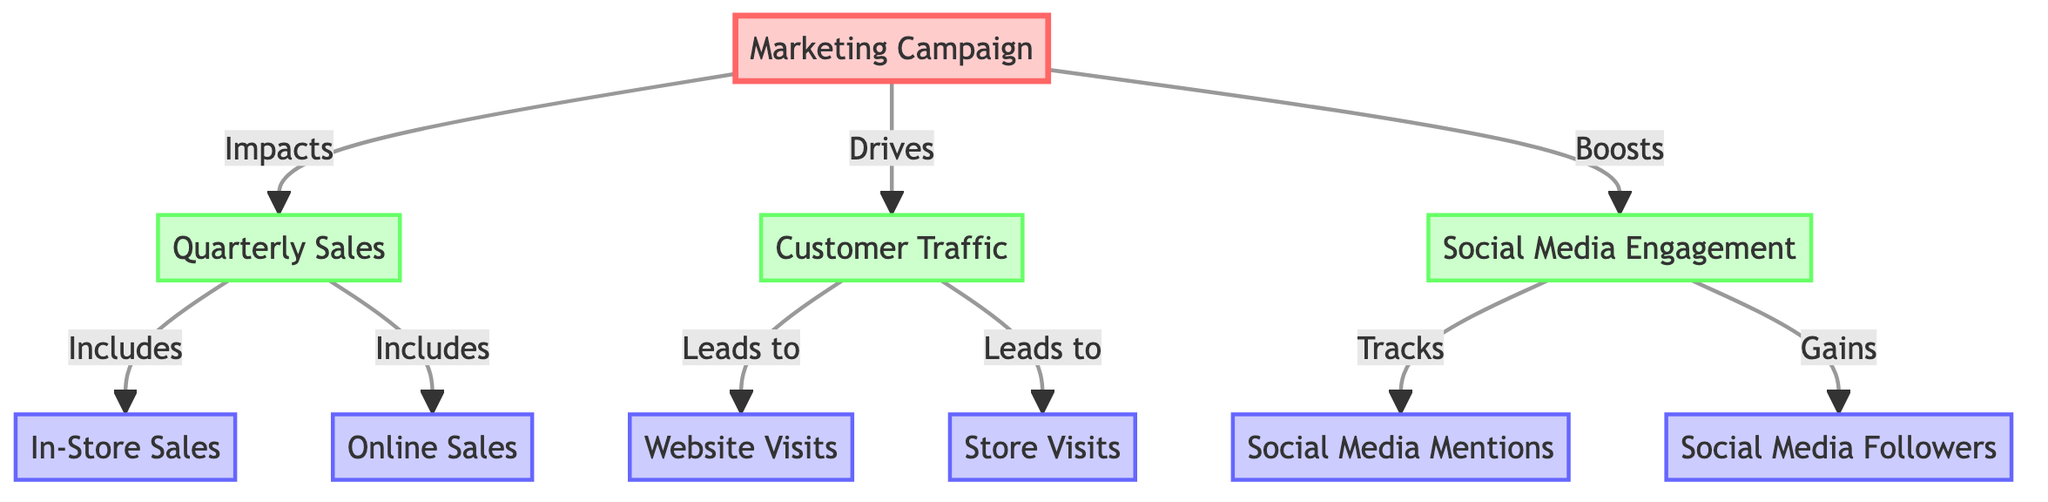What's the primary node in this diagram? The primary node, which serves as the starting point for the relationships connecting various metrics, is "Marketing Campaign." It is depicted prominently with the label indicating its role.
Answer: Marketing Campaign How many main metric nodes are there? The main metric nodes are "Quarterly Sales," "Customer Traffic," and "Social Media Engagement." Counting these nodes provides the answer.
Answer: Three What does the marketing campaign impact directly? The marketing campaign directly impacts quarterly sales, as indicated by the connection labeled "Impacts." This relationship shows a straightforward influence in the diagram.
Answer: Quarterly Sales What metric is included in quarterly sales? In quarterly sales, both in-store sales and online sales are included, suggesting these are components tracked under the broader sales category.
Answer: In-Store Sales and Online Sales Which metric leads to website visits? Customer traffic leads to website visits based on the connection labeled "Leads to," indicating that increased traffic directs customers to the website more frequently.
Answer: Customer Traffic What effect does the marketing campaign have on social media engagement? The marketing campaign boosts social media engagement, indicated by the labeled arrow showing the direct influence of the campaign on engagement metrics.
Answer: Boosts How many submetrics are associated with social media engagement? The associated submetrics are "Social Media Mentions" and "Social Media Followers," counted as the elements branching from "Social Media Engagement."
Answer: Two Which metric tracks mentions on social media? Social media engagement tracks social media mentions, illustrated by the labeled relationship indicating this tracking effect.
Answer: Social Media Mentions Which three metrics are influenced by the marketing campaign? The marketing campaign influences quarterly sales, customer traffic, and social media engagement, as seen by the arrows depicting the direct relationships.
Answer: Quarterly Sales, Customer Traffic, and Social Media Engagement 